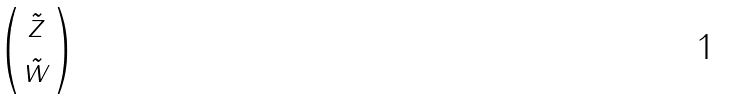<formula> <loc_0><loc_0><loc_500><loc_500>\begin{pmatrix} \tilde { z } \\ \tilde { w } \end{pmatrix}</formula> 